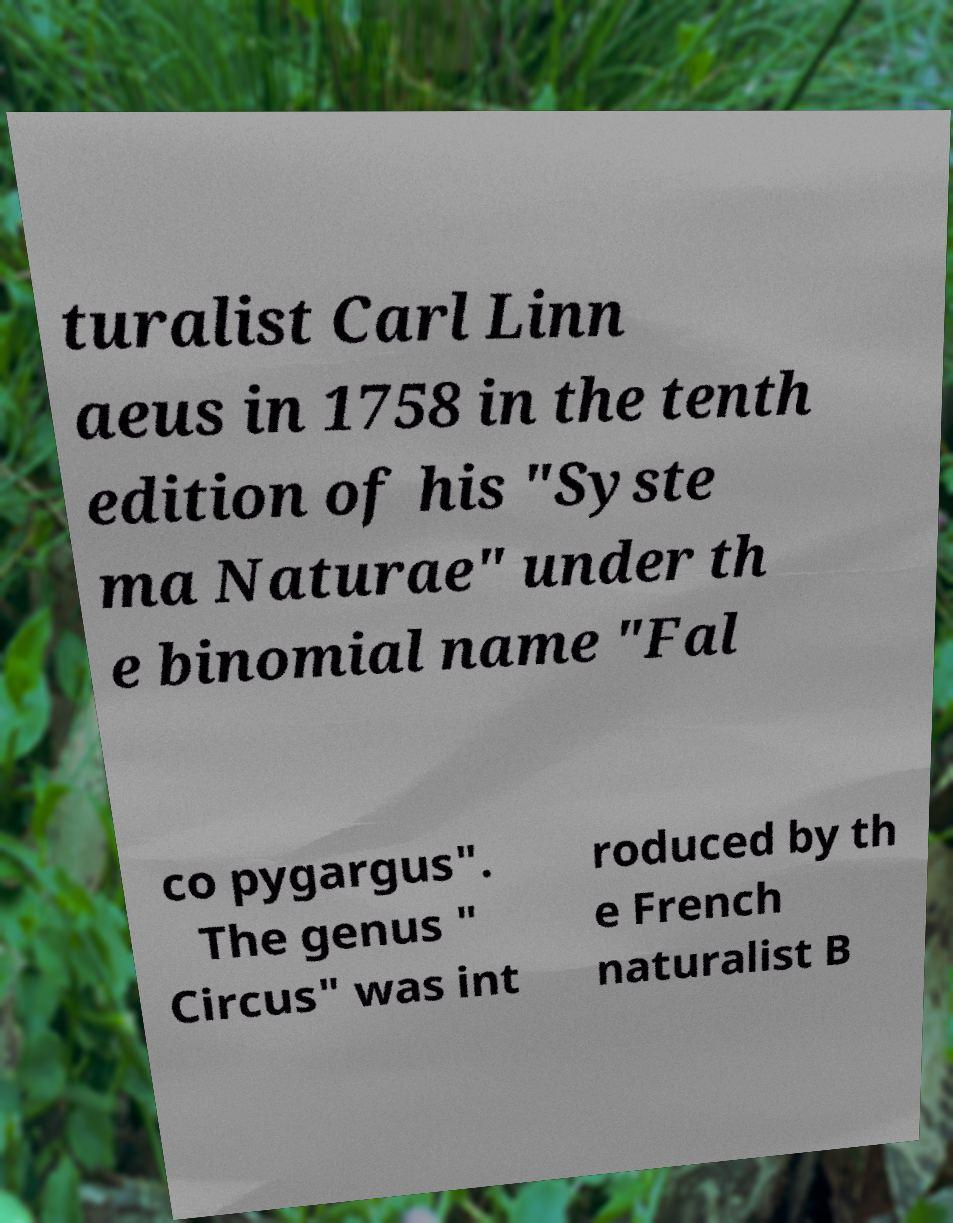For documentation purposes, I need the text within this image transcribed. Could you provide that? turalist Carl Linn aeus in 1758 in the tenth edition of his "Syste ma Naturae" under th e binomial name "Fal co pygargus". The genus " Circus" was int roduced by th e French naturalist B 